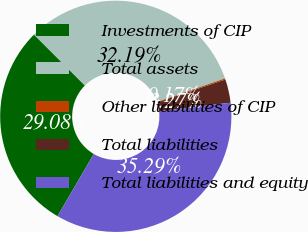<chart> <loc_0><loc_0><loc_500><loc_500><pie_chart><fcel>Investments of CIP<fcel>Total assets<fcel>Other liabilities of CIP<fcel>Total liabilities<fcel>Total liabilities and equity<nl><fcel>29.08%<fcel>32.19%<fcel>0.17%<fcel>3.27%<fcel>35.29%<nl></chart> 